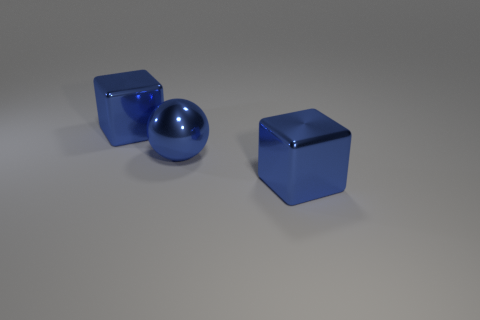What number of rubber objects are big blue things or large blue cubes?
Your answer should be very brief. 0. What number of objects are either yellow matte things or large cubes that are in front of the metal sphere?
Ensure brevity in your answer.  1. Is there a blue block behind the blue shiny thing that is right of the blue sphere?
Make the answer very short. Yes. How many brown objects are either shiny blocks or metallic balls?
Your response must be concise. 0. What number of other objects are there of the same color as the large ball?
Your answer should be very brief. 2. There is a blue block in front of the blue shiny cube behind the large sphere; what size is it?
Provide a succinct answer. Large. There is a big blue thing that is in front of the large blue sphere; what is its shape?
Offer a very short reply. Cube. What number of other blue metal spheres have the same size as the blue metal sphere?
Ensure brevity in your answer.  0. How many large blue metal spheres are in front of the big blue shiny ball?
Offer a terse response. 0. Are there more blue metal balls than tiny cyan metallic cylinders?
Give a very brief answer. Yes. 